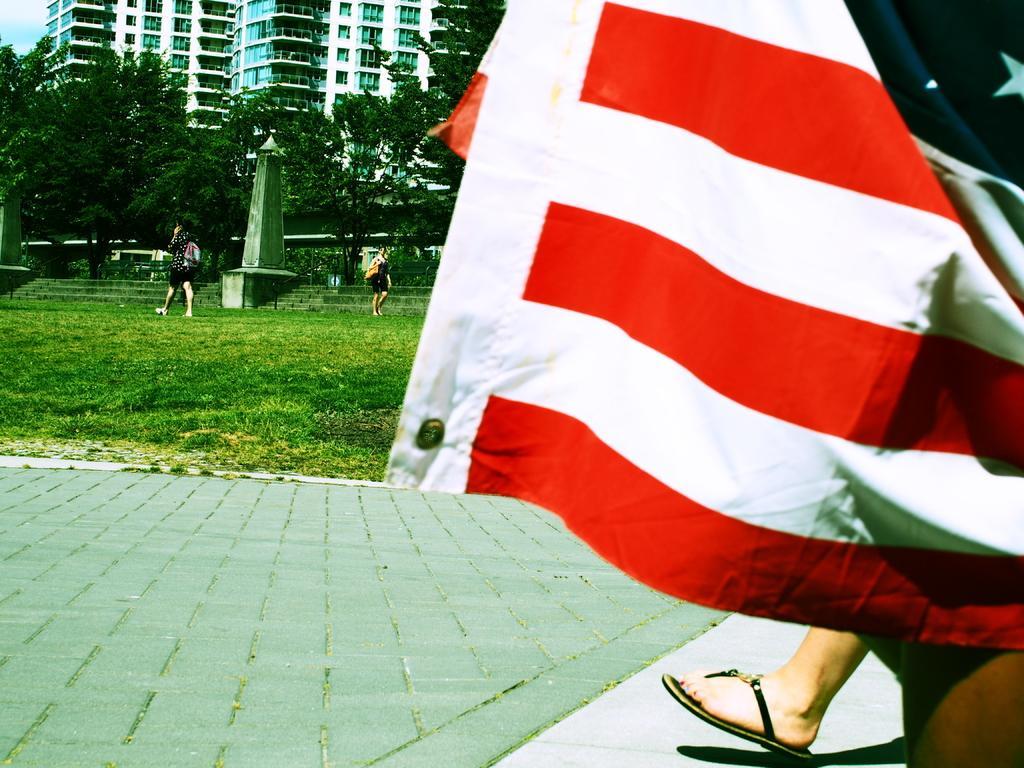Could you give a brief overview of what you see in this image? In this image I can see the ground, legs and a flag which is red, white and black in color. In the background I can see some grass, few persons standing, a pole, few stairs, few trees, few buildings and the sky. 